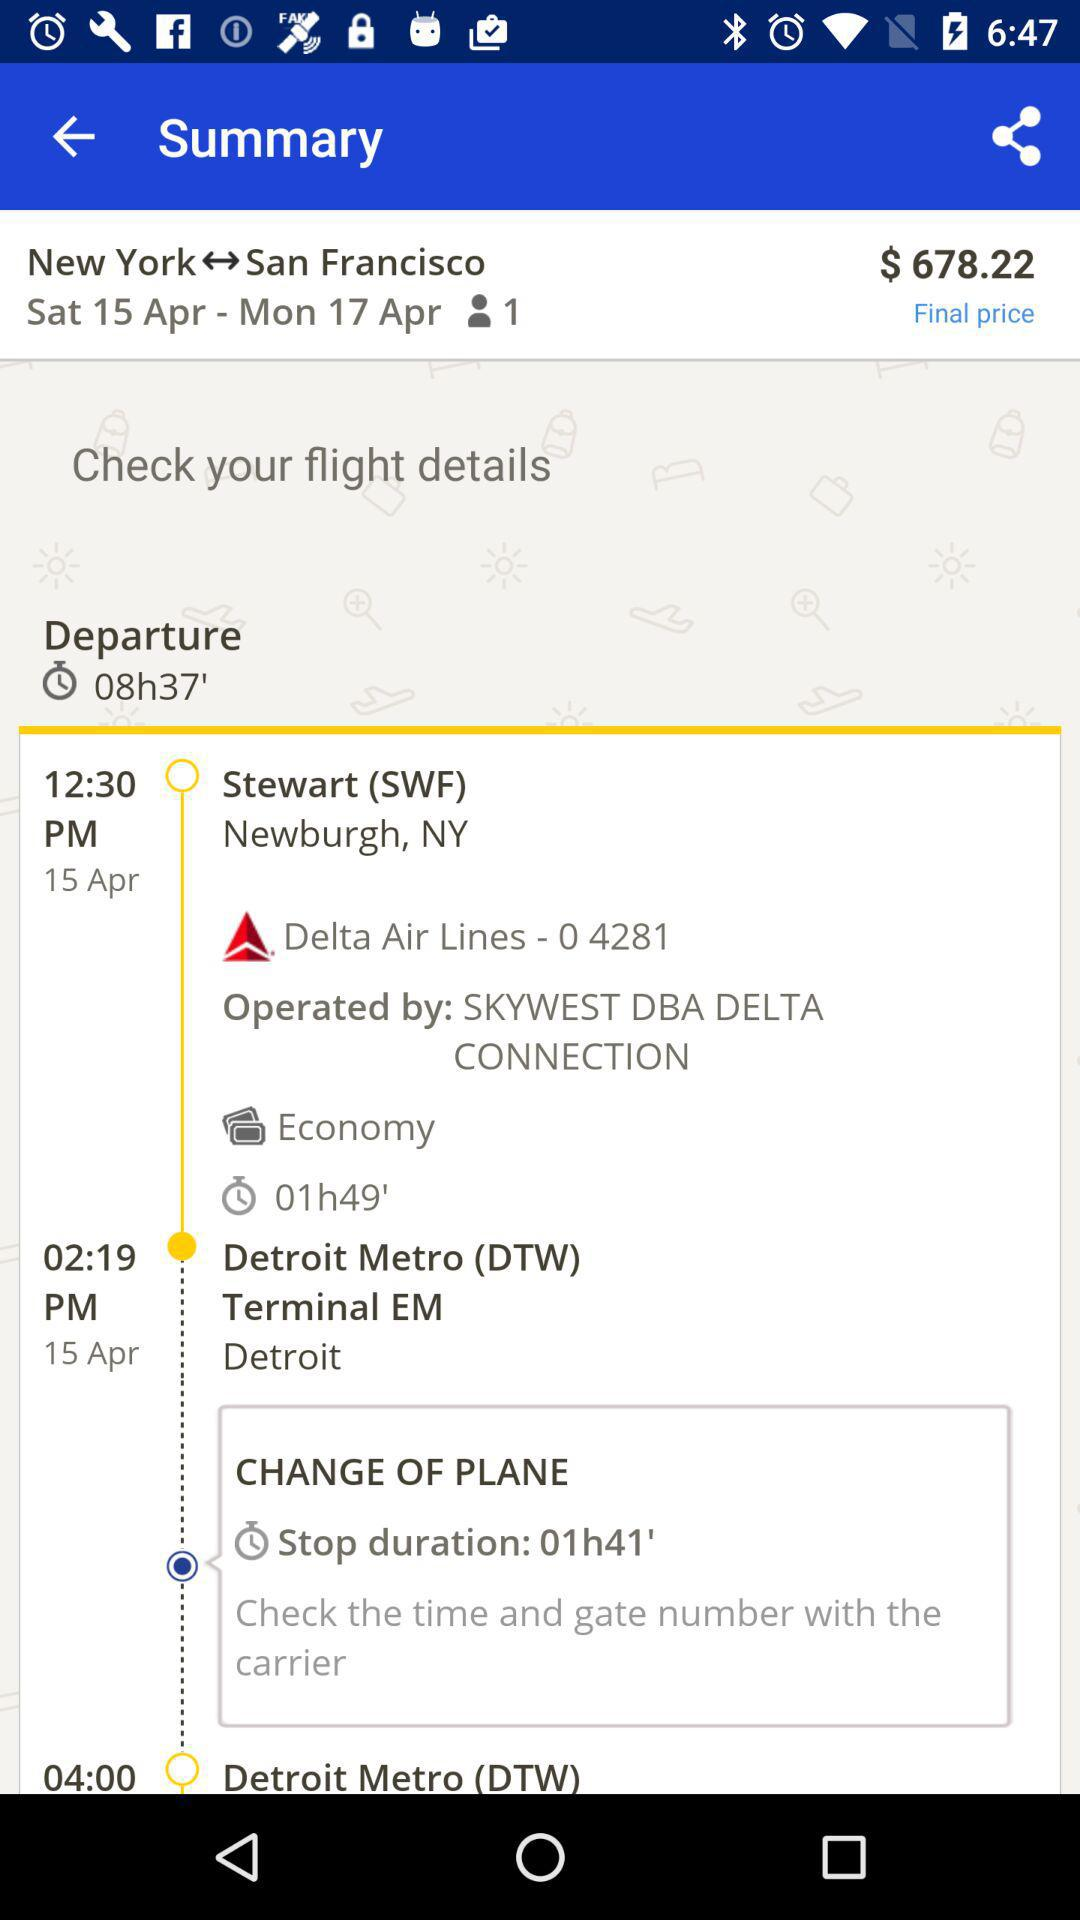What is the mentioned class? The mentioned class is economy. 